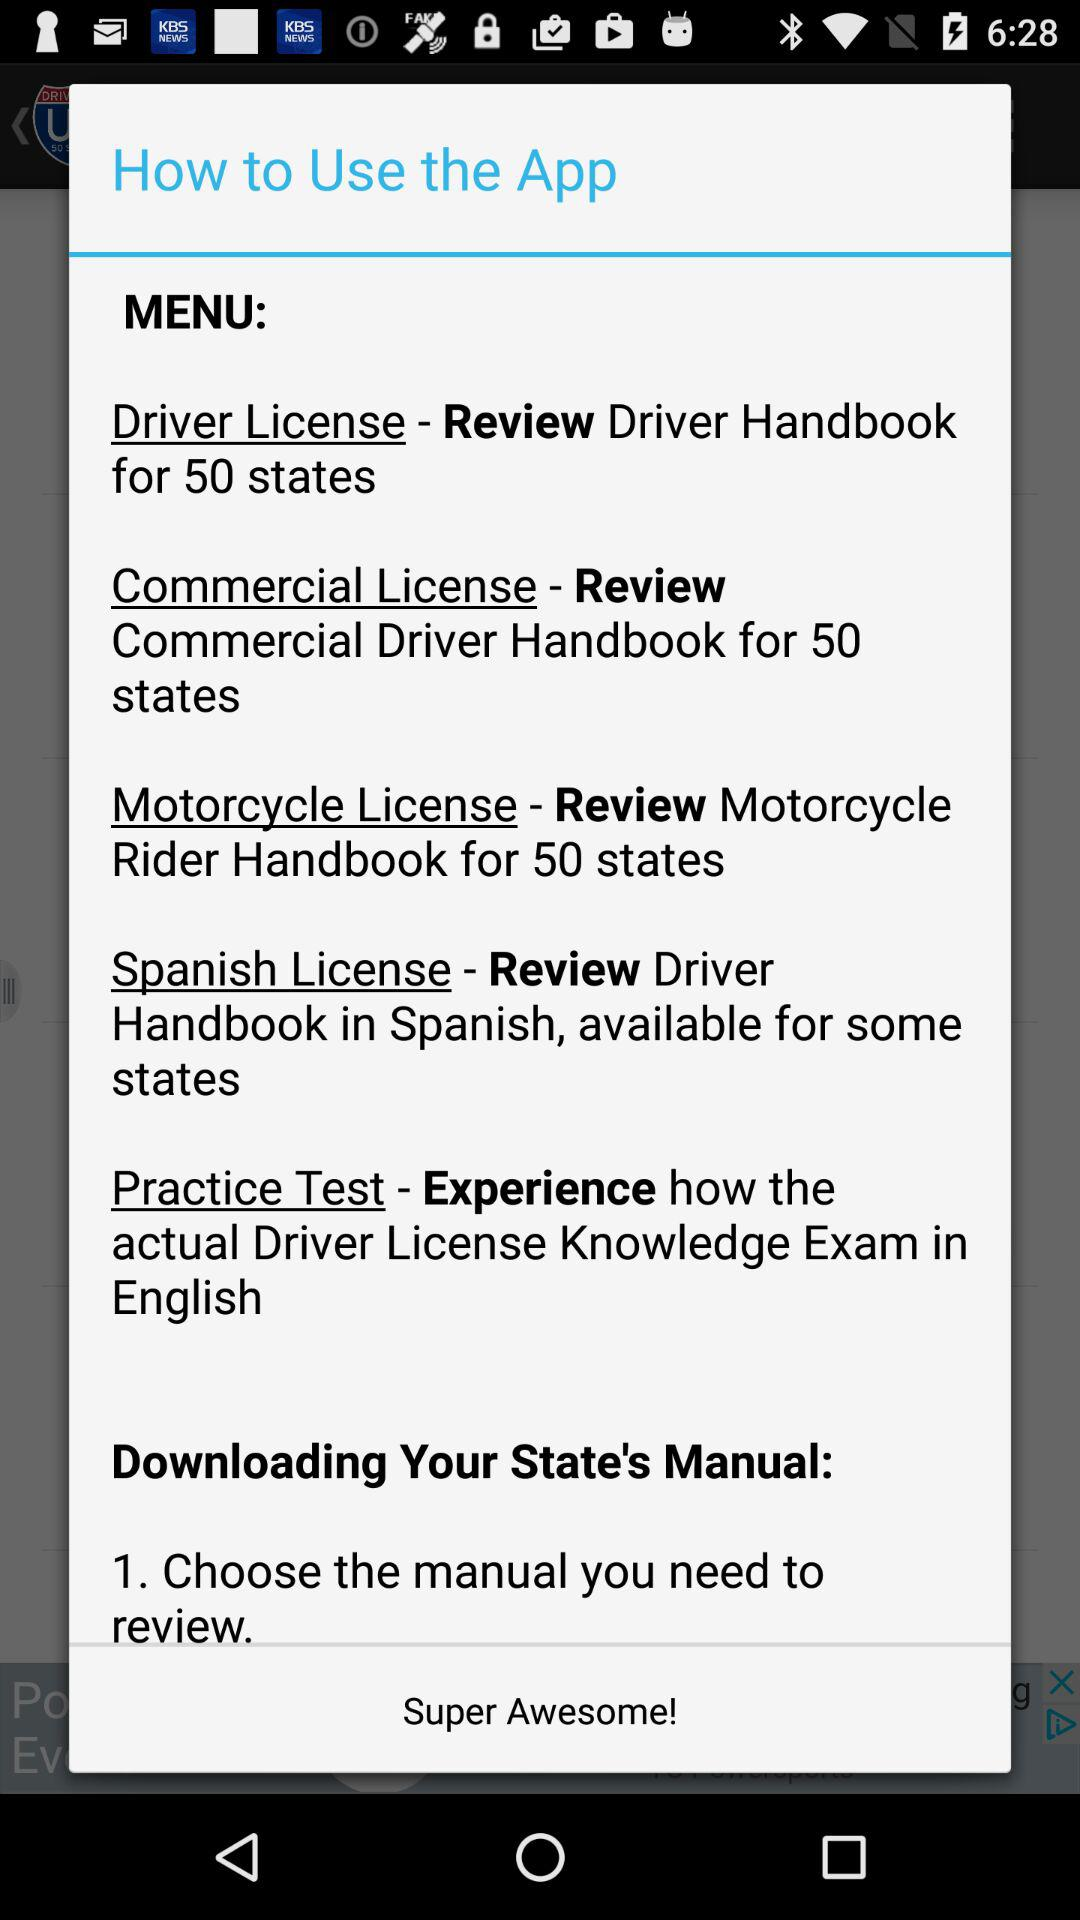In how many states is the driver's handbook available? The driver's handbook is available in 50 states. 